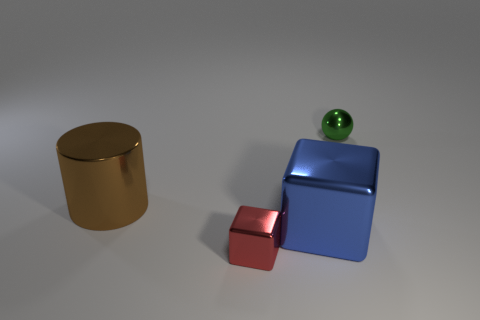What shape is the object that is to the right of the large brown object and left of the blue metal cube?
Keep it short and to the point. Cube. There is another thing that is the same shape as the red thing; what is its size?
Make the answer very short. Large. Are there fewer brown things that are in front of the red object than cyan objects?
Your answer should be very brief. No. There is a metallic object that is to the left of the red metallic object; what size is it?
Offer a very short reply. Large. There is a large metallic object that is the same shape as the tiny red metal object; what color is it?
Ensure brevity in your answer.  Blue. Is there anything else that is the same shape as the tiny green metal object?
Make the answer very short. No. Are there any small things that are in front of the tiny metallic thing to the right of the tiny shiny thing to the left of the green sphere?
Offer a terse response. Yes. How many other small things are the same material as the brown object?
Your answer should be compact. 2. There is a thing that is behind the brown cylinder; does it have the same size as the cube right of the tiny red cube?
Give a very brief answer. No. There is a cube behind the small metal object that is to the left of the small thing right of the large blue shiny block; what is its color?
Offer a very short reply. Blue. 